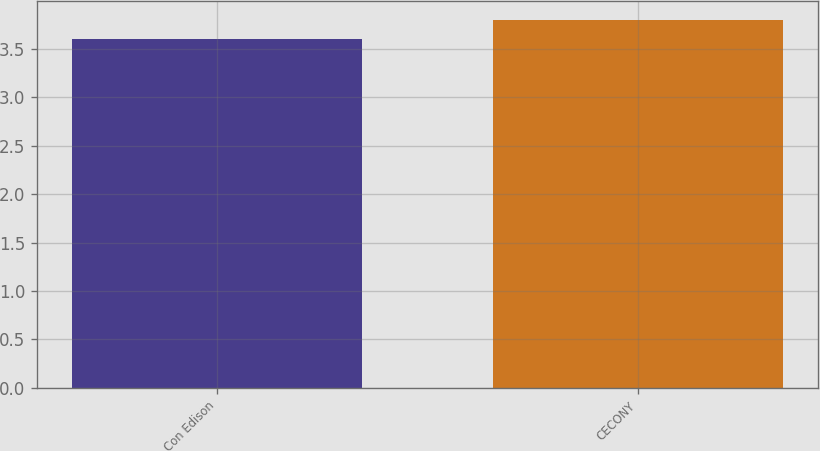Convert chart. <chart><loc_0><loc_0><loc_500><loc_500><bar_chart><fcel>Con Edison<fcel>CECONY<nl><fcel>3.6<fcel>3.8<nl></chart> 